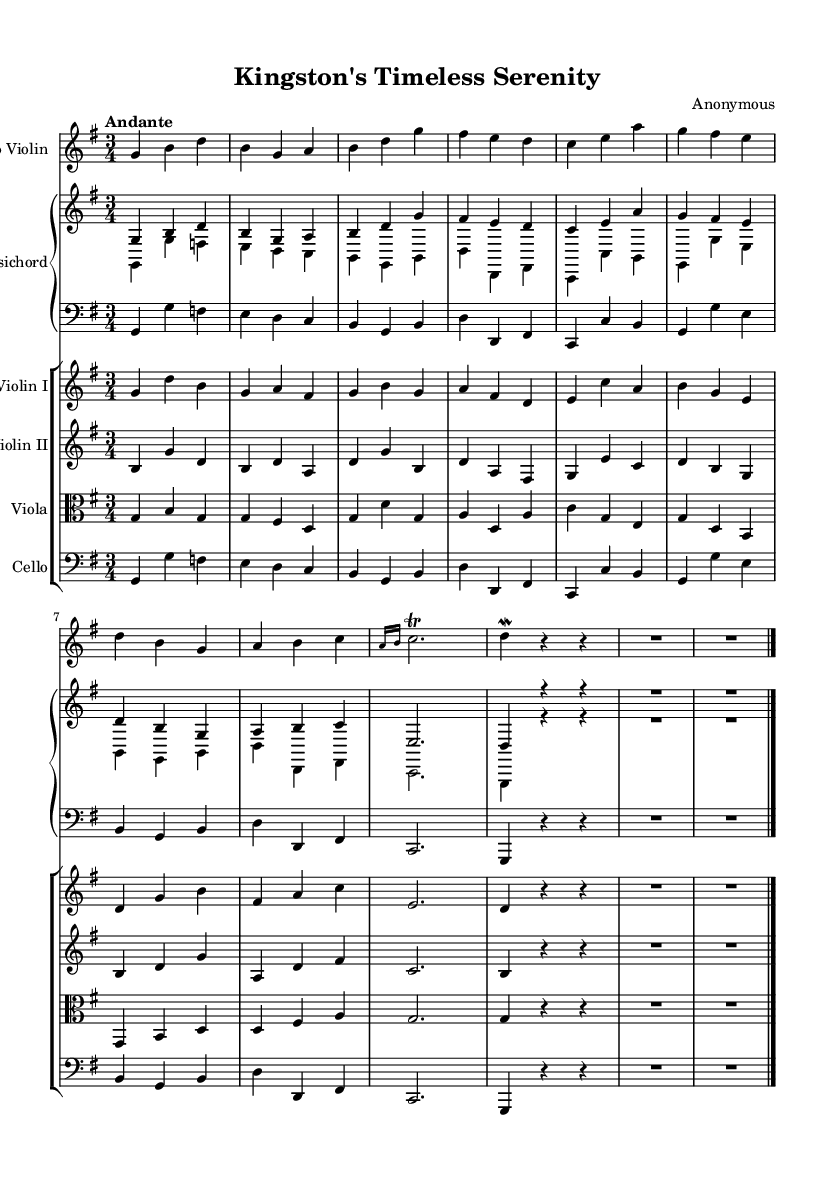What is the key signature of this music? The key signature indicated at the beginning of the sheet music shows one sharp, suggesting the piece is in G major.
Answer: G major What is the time signature? The time signature appears at the beginning of the score, and it is shown as 3/4, which means there are three beats in each measure and a quarter note gets one beat.
Answer: 3/4 What is the tempo marking? The tempo marking at the beginning of the sheet music reads "Andante," which indicates a moderately slow pace for the piece.
Answer: Andante How many measures are in the solo violin part? Counting the measures in the solo violin part, there are a total of 8 measures presented in this excerpt.
Answer: 8 Which instruments are included in this concerto? The written score indicates a solo violin, two violins, a viola, a cello, and a harpsichord, which are common in Baroque concertos.
Answer: Solo violin, two violins, viola, cello, harpsichord Is there a trill in the piece? In the solo violin part, the notation shows a trill marked over the note C, specifically indicated as a grace note before it, confirming that a trill occurs.
Answer: Yes 